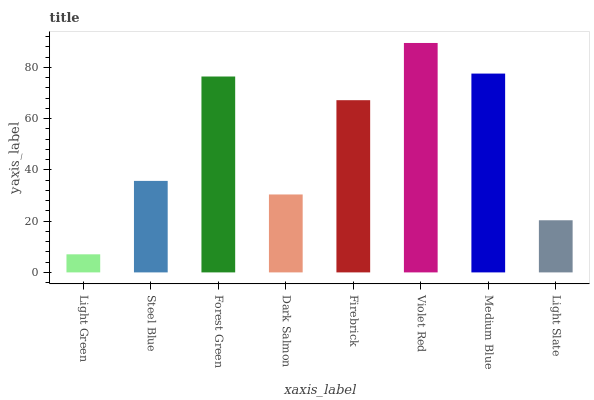Is Light Green the minimum?
Answer yes or no. Yes. Is Violet Red the maximum?
Answer yes or no. Yes. Is Steel Blue the minimum?
Answer yes or no. No. Is Steel Blue the maximum?
Answer yes or no. No. Is Steel Blue greater than Light Green?
Answer yes or no. Yes. Is Light Green less than Steel Blue?
Answer yes or no. Yes. Is Light Green greater than Steel Blue?
Answer yes or no. No. Is Steel Blue less than Light Green?
Answer yes or no. No. Is Firebrick the high median?
Answer yes or no. Yes. Is Steel Blue the low median?
Answer yes or no. Yes. Is Medium Blue the high median?
Answer yes or no. No. Is Forest Green the low median?
Answer yes or no. No. 